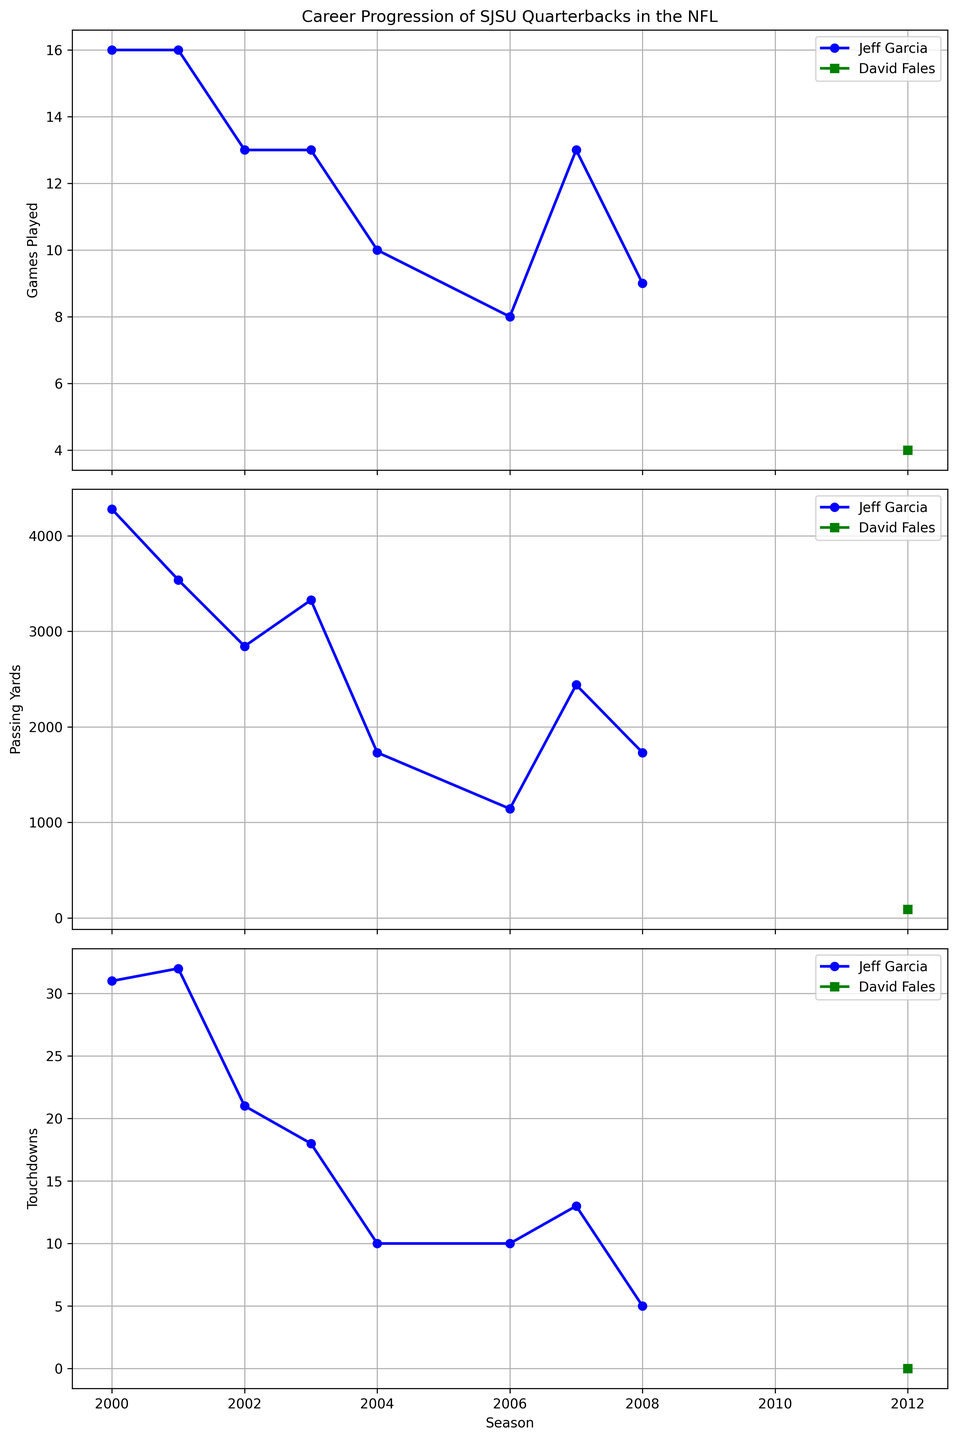What is the trend in Jeff Garcia's games played from 2000 to 2008? To answer this, observe the line chart for Games Played for Jeff Garcia between 2000 and 2008. The plot shows that the games played start at 16 in 2000, remain at 16 in 2001, then fluctuate but generally decrease over time, reaching as low as 8 games in 2006 and then slightly increasing again but never returning to the initial high.
Answer: Decreasing trend In which season did Jeff Garcia achieve his highest number of touchdown passes, and how many were there? Looking at the line chart for Touchdowns, observe Jeff Garcia's data points where each point corresponds to a season. The highest point for touchdowns is in 2001, where he scored 32 touchdowns.
Answer: 2001, 32 How does David Fales' passing yards compare to Jeff Garcia's lowest passing yards in a season? Examine both players' line charts for Passing Yards. David Fales has a single data point at 91 yards in 2012. Jeff Garcia's lowest passing yards occur in 2006 and 2008 with 1731 yards each. Thus, Fales' passing yards are significantly lower than Garcia's lowest.
Answer: Fales has significantly fewer passing yards Which player had more seasons with over 3,000 passing yards, Jeff Garcia or David Fales? From the Passing Yards line chart, identify the number of seasons each player surpasses the 3,000-yard mark. Jeff Garcia exceeded 3,000 yards in 2000, 2001, and 2003. David Fales never exceeded 3,000 passing yards.
Answer: Jeff Garcia What is the average number of games Jeff Garcia played between 2000 and 2008? Sum the number of games Jeff Garcia played across all seasons (16+16+13+13+10+8+13+9) and divide by the total number of seasons (8). 88/8 = 11 games on average per season.
Answer: 11 games Did Jeff Garcia's touchdowns per season generally increase, decrease, or stay the same over his career? Examine the Touchdowns line chart for Jeff Garcia. The touchdown count starts high, peaks in 2001, then shows a general downward trend but with some fluctuations. Overall, the trend is decreasing.
Answer: Decrease In which season did Jeff Garcia play the fewest games, and how many did he play? Look at the Games Played line chart for Jeff Garcia. The lowest point is in 2006, where he played 8 games.
Answer: 2006, 8 games Compare Jeff Garcia's touchdown counts between seasons where he played the same number of games. Jeff Garcia played 16 games in both 2000 and 2001. Compare the touchdowns: 31 in 2000 and 32 in 2001. No other identical game counts appear with varying touchdowns. Thus, in these two seasons, the touchdowns increased slightly from 31 to 32.
Answer: Increased from 31 to 32 How many seasons did Jeff Garcia play more than 10 games? Check the Games Played line chart for Jeff Garcia and count the seasons where the number of games is greater than 10. Those seasons are 2000, 2001, 2002, 2003, 2007. There are 5 such seasons.
Answer: 5 seasons 